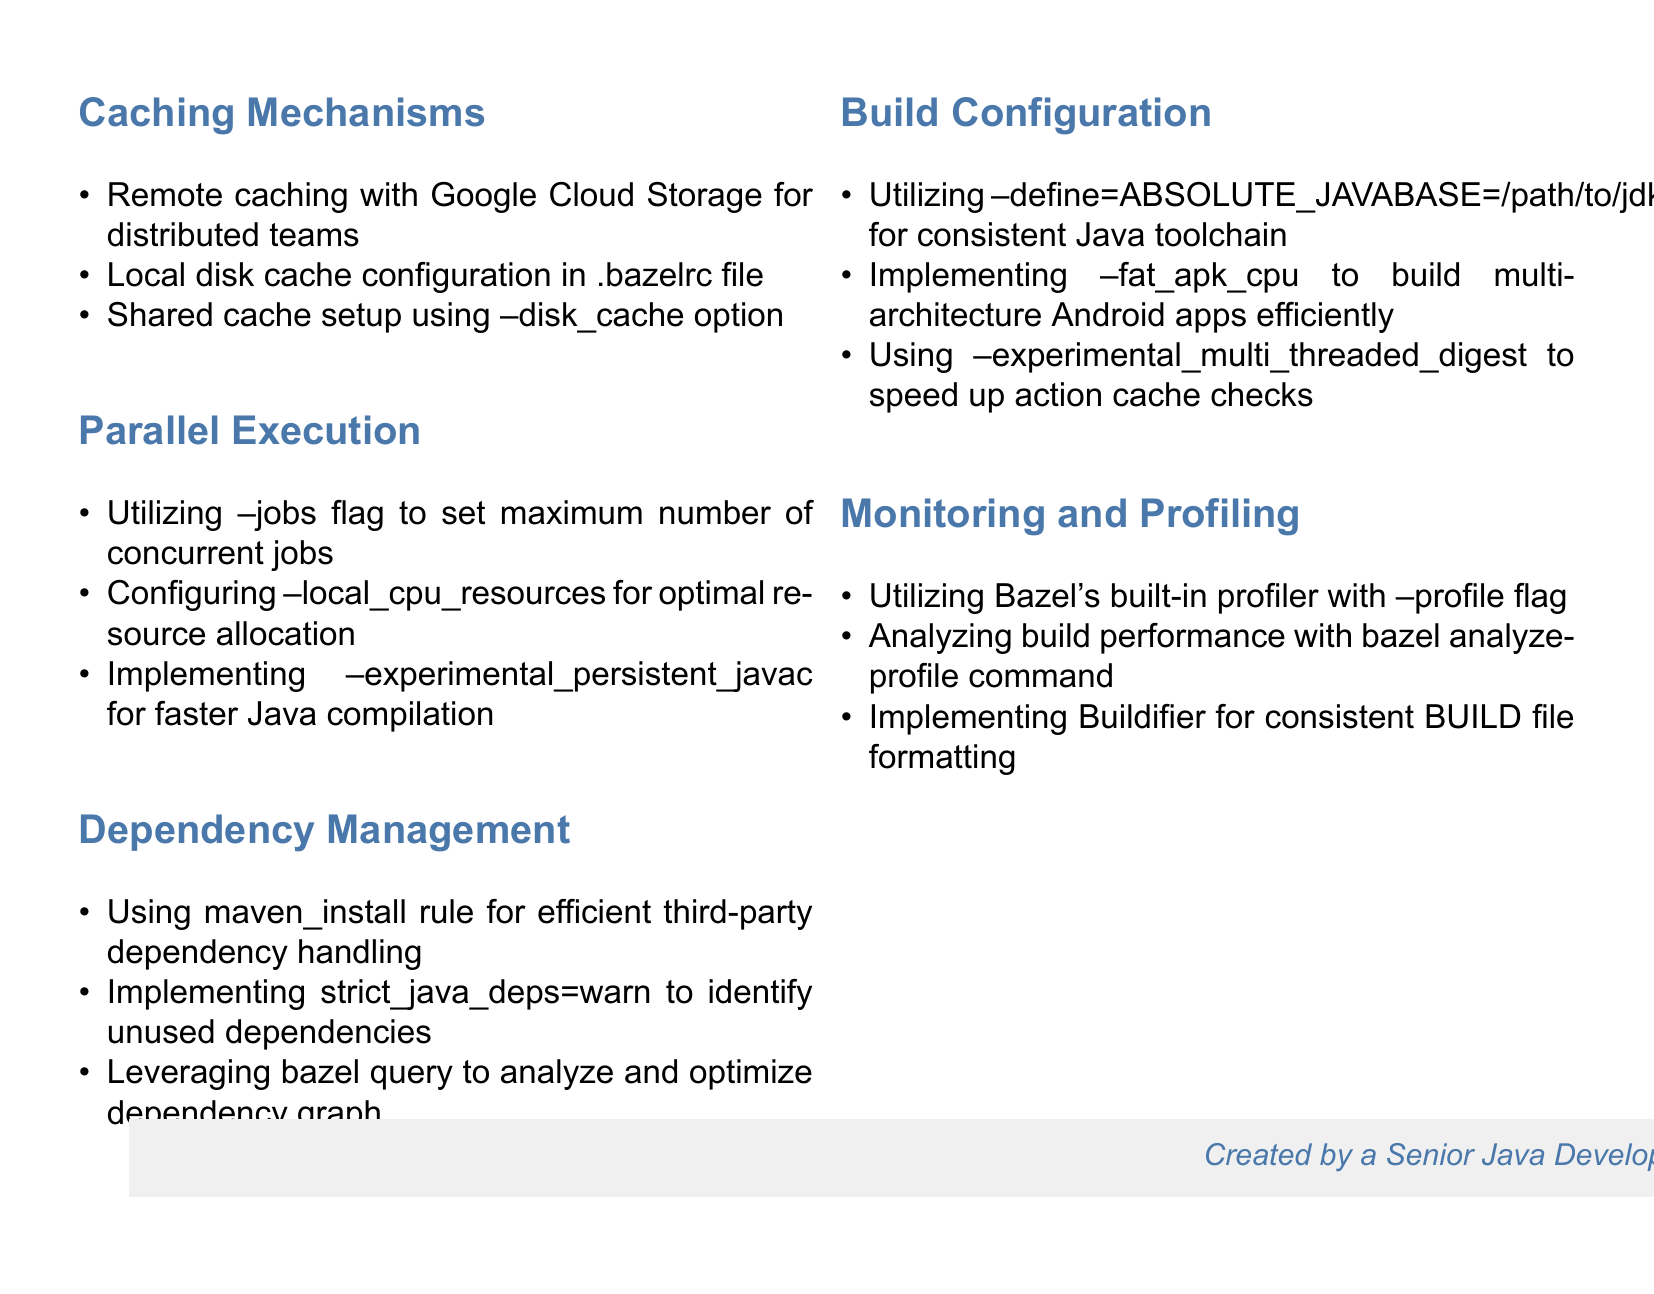what caching mechanism is suggested for distributed teams? The document mentions remote caching specifically for distributed teams.
Answer: Remote caching with Google Cloud Storage what flag is used to configure the maximum number of concurrent jobs? The document states that the --jobs flag is utilized for setting the maximum number of concurrent jobs.
Answer: --jobs what is recommended to analyze and optimize the dependency graph? The document suggests leveraging bazel query to analyze and optimize the dependency graph.
Answer: bazel query which option is used to speed up action cache checks? The document highlights the --experimental_multi_threaded_digest option for speeding up action cache checks.
Answer: --experimental_multi_threaded_digest how can one handle third-party dependencies efficiently? The document advises using the maven_install rule for efficient handling of third-party dependencies.
Answer: maven_install rule what command is used for analyzing build performance? The document explains that the bazel analyze-profile command is used for analyzing build performance.
Answer: bazel analyze-profile which flag can be used for Java compilation speed improvement? The document indicates that --experimental_persistent_javac can be implemented for faster Java compilation.
Answer: --experimental_persistent_javac how can build files be consistently formatted? The document notes that Buildifier can be implemented for consistent BUILD file formatting.
Answer: Buildifier 